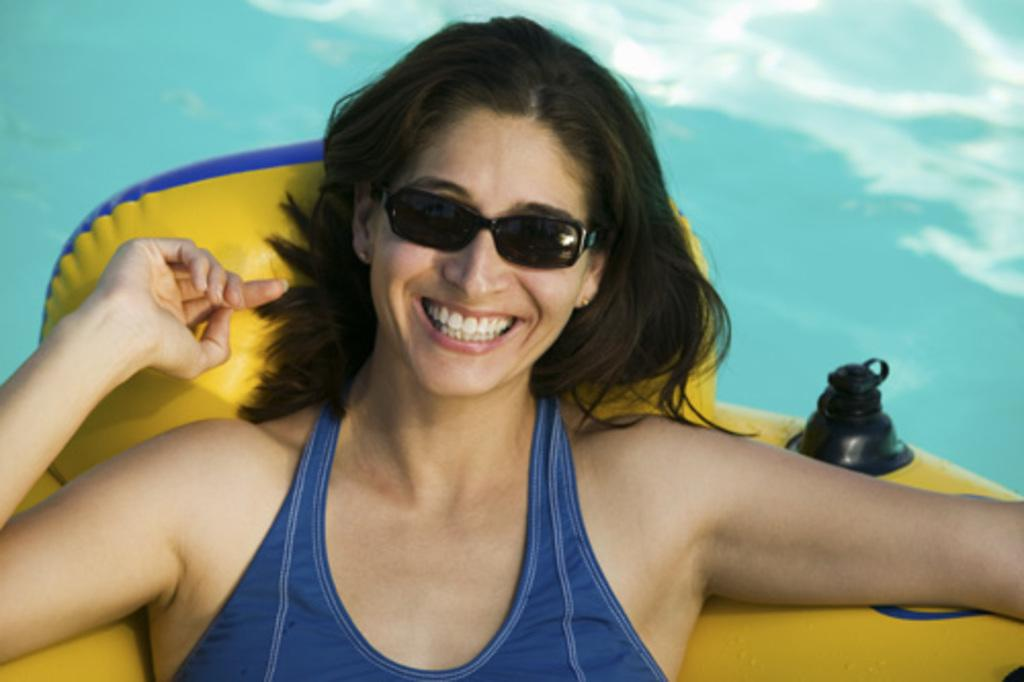Who or what is the main subject in the image? There is a person in the image. What is the person doing in the image? The person is lying on a water tube. Can you describe the water tube? The water tube is yellow and blue in color. What can be seen in the background of the image? The background of the image is blue. Is there a cub playing with the water tube in the image? No, there is no cub present in the image. 